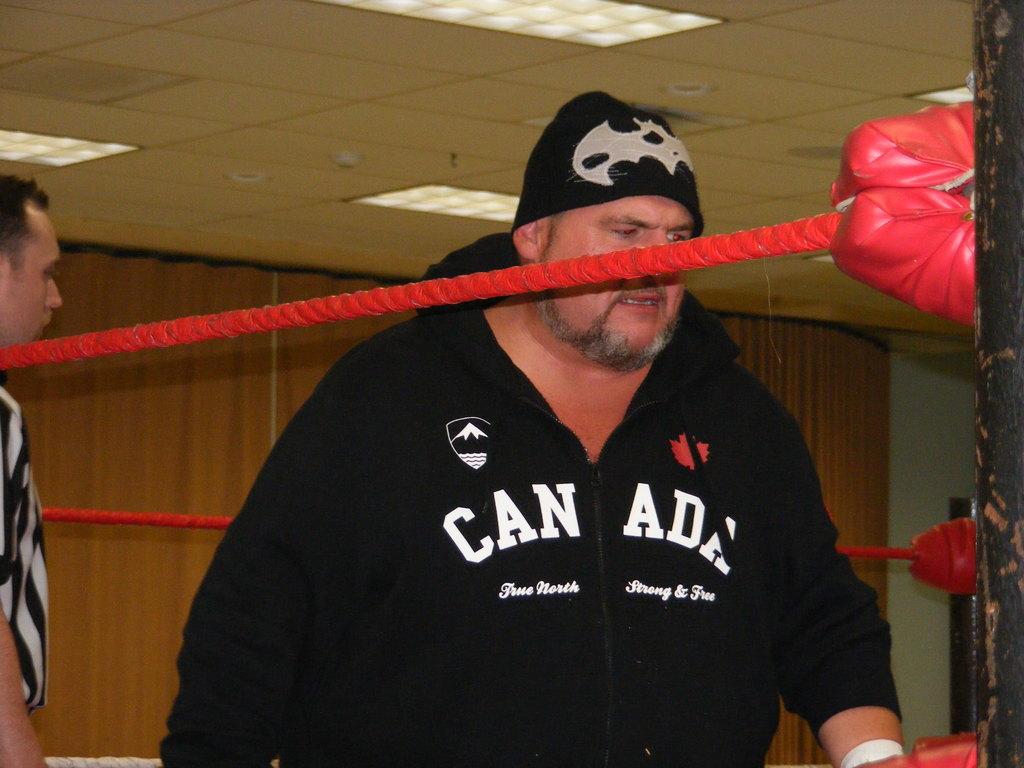What is the motto written under canada?
Offer a terse response. True north strong and free. 